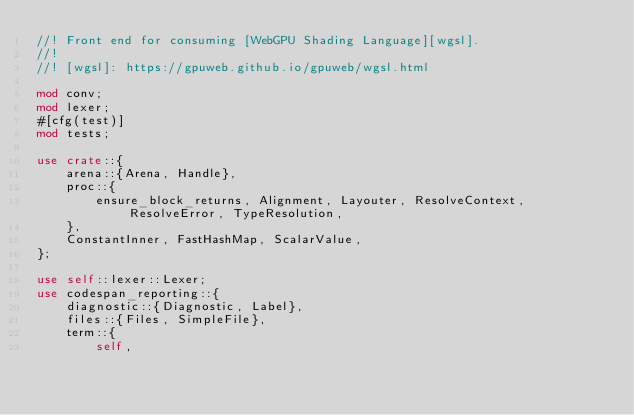<code> <loc_0><loc_0><loc_500><loc_500><_Rust_>//! Front end for consuming [WebGPU Shading Language][wgsl].
//!
//! [wgsl]: https://gpuweb.github.io/gpuweb/wgsl.html

mod conv;
mod lexer;
#[cfg(test)]
mod tests;

use crate::{
    arena::{Arena, Handle},
    proc::{
        ensure_block_returns, Alignment, Layouter, ResolveContext, ResolveError, TypeResolution,
    },
    ConstantInner, FastHashMap, ScalarValue,
};

use self::lexer::Lexer;
use codespan_reporting::{
    diagnostic::{Diagnostic, Label},
    files::{Files, SimpleFile},
    term::{
        self,</code> 